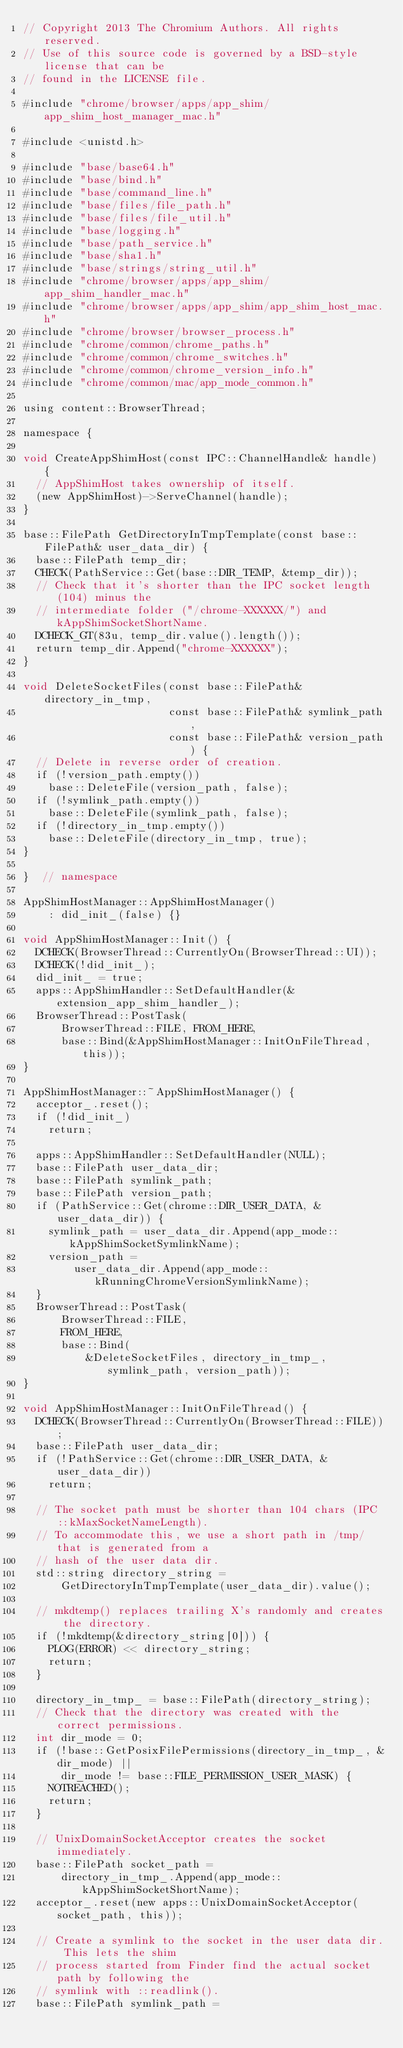<code> <loc_0><loc_0><loc_500><loc_500><_ObjectiveC_>// Copyright 2013 The Chromium Authors. All rights reserved.
// Use of this source code is governed by a BSD-style license that can be
// found in the LICENSE file.

#include "chrome/browser/apps/app_shim/app_shim_host_manager_mac.h"

#include <unistd.h>

#include "base/base64.h"
#include "base/bind.h"
#include "base/command_line.h"
#include "base/files/file_path.h"
#include "base/files/file_util.h"
#include "base/logging.h"
#include "base/path_service.h"
#include "base/sha1.h"
#include "base/strings/string_util.h"
#include "chrome/browser/apps/app_shim/app_shim_handler_mac.h"
#include "chrome/browser/apps/app_shim/app_shim_host_mac.h"
#include "chrome/browser/browser_process.h"
#include "chrome/common/chrome_paths.h"
#include "chrome/common/chrome_switches.h"
#include "chrome/common/chrome_version_info.h"
#include "chrome/common/mac/app_mode_common.h"

using content::BrowserThread;

namespace {

void CreateAppShimHost(const IPC::ChannelHandle& handle) {
  // AppShimHost takes ownership of itself.
  (new AppShimHost)->ServeChannel(handle);
}

base::FilePath GetDirectoryInTmpTemplate(const base::FilePath& user_data_dir) {
  base::FilePath temp_dir;
  CHECK(PathService::Get(base::DIR_TEMP, &temp_dir));
  // Check that it's shorter than the IPC socket length (104) minus the
  // intermediate folder ("/chrome-XXXXXX/") and kAppShimSocketShortName.
  DCHECK_GT(83u, temp_dir.value().length());
  return temp_dir.Append("chrome-XXXXXX");
}

void DeleteSocketFiles(const base::FilePath& directory_in_tmp,
                       const base::FilePath& symlink_path,
                       const base::FilePath& version_path) {
  // Delete in reverse order of creation.
  if (!version_path.empty())
    base::DeleteFile(version_path, false);
  if (!symlink_path.empty())
    base::DeleteFile(symlink_path, false);
  if (!directory_in_tmp.empty())
    base::DeleteFile(directory_in_tmp, true);
}

}  // namespace

AppShimHostManager::AppShimHostManager()
    : did_init_(false) {}

void AppShimHostManager::Init() {
  DCHECK(BrowserThread::CurrentlyOn(BrowserThread::UI));
  DCHECK(!did_init_);
  did_init_ = true;
  apps::AppShimHandler::SetDefaultHandler(&extension_app_shim_handler_);
  BrowserThread::PostTask(
      BrowserThread::FILE, FROM_HERE,
      base::Bind(&AppShimHostManager::InitOnFileThread, this));
}

AppShimHostManager::~AppShimHostManager() {
  acceptor_.reset();
  if (!did_init_)
    return;

  apps::AppShimHandler::SetDefaultHandler(NULL);
  base::FilePath user_data_dir;
  base::FilePath symlink_path;
  base::FilePath version_path;
  if (PathService::Get(chrome::DIR_USER_DATA, &user_data_dir)) {
    symlink_path = user_data_dir.Append(app_mode::kAppShimSocketSymlinkName);
    version_path =
        user_data_dir.Append(app_mode::kRunningChromeVersionSymlinkName);
  }
  BrowserThread::PostTask(
      BrowserThread::FILE,
      FROM_HERE,
      base::Bind(
          &DeleteSocketFiles, directory_in_tmp_, symlink_path, version_path));
}

void AppShimHostManager::InitOnFileThread() {
  DCHECK(BrowserThread::CurrentlyOn(BrowserThread::FILE));
  base::FilePath user_data_dir;
  if (!PathService::Get(chrome::DIR_USER_DATA, &user_data_dir))
    return;

  // The socket path must be shorter than 104 chars (IPC::kMaxSocketNameLength).
  // To accommodate this, we use a short path in /tmp/ that is generated from a
  // hash of the user data dir.
  std::string directory_string =
      GetDirectoryInTmpTemplate(user_data_dir).value();

  // mkdtemp() replaces trailing X's randomly and creates the directory.
  if (!mkdtemp(&directory_string[0])) {
    PLOG(ERROR) << directory_string;
    return;
  }

  directory_in_tmp_ = base::FilePath(directory_string);
  // Check that the directory was created with the correct permissions.
  int dir_mode = 0;
  if (!base::GetPosixFilePermissions(directory_in_tmp_, &dir_mode) ||
      dir_mode != base::FILE_PERMISSION_USER_MASK) {
    NOTREACHED();
    return;
  }

  // UnixDomainSocketAcceptor creates the socket immediately.
  base::FilePath socket_path =
      directory_in_tmp_.Append(app_mode::kAppShimSocketShortName);
  acceptor_.reset(new apps::UnixDomainSocketAcceptor(socket_path, this));

  // Create a symlink to the socket in the user data dir. This lets the shim
  // process started from Finder find the actual socket path by following the
  // symlink with ::readlink().
  base::FilePath symlink_path =</code> 